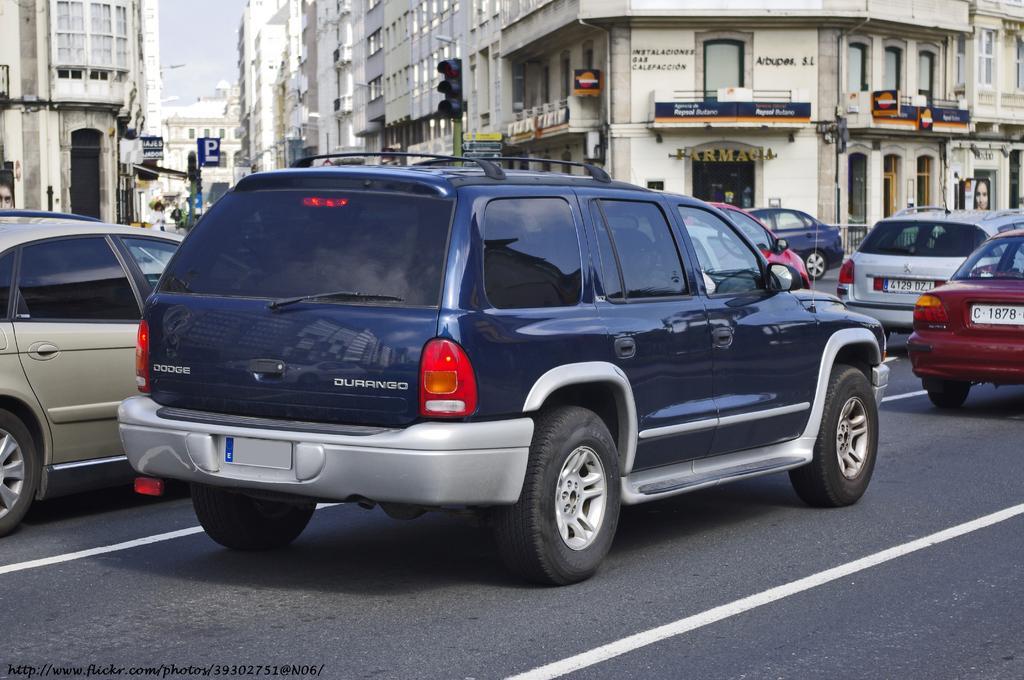How would you summarize this image in a sentence or two? In this image I can see number of vehicles, number of buildings, number of boards, signal lights, poles and I can see white lines on this road. On these words I can see something is written. 